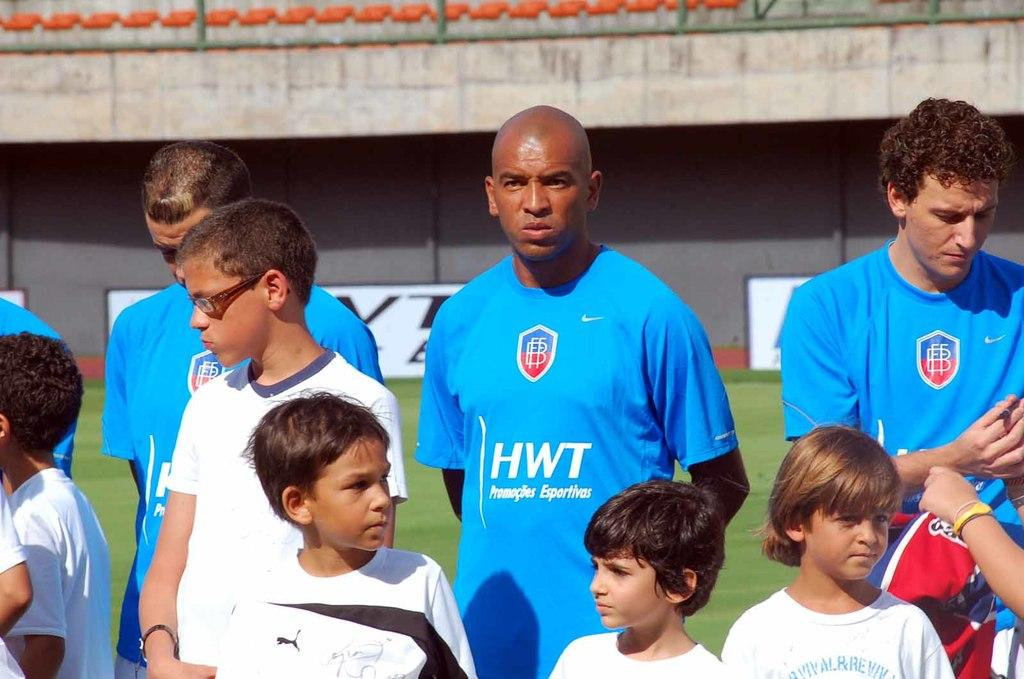<image>
Write a terse but informative summary of the picture. Team members from HWT training children with white tshirts 